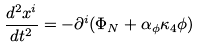<formula> <loc_0><loc_0><loc_500><loc_500>\frac { d ^ { 2 } x ^ { i } } { d t ^ { 2 } } = - \partial ^ { i } ( \Phi _ { N } + \alpha _ { \phi } \kappa _ { 4 } \phi )</formula> 